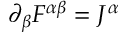<formula> <loc_0><loc_0><loc_500><loc_500>\partial _ { \beta } F ^ { \alpha \beta } = J ^ { \alpha }</formula> 